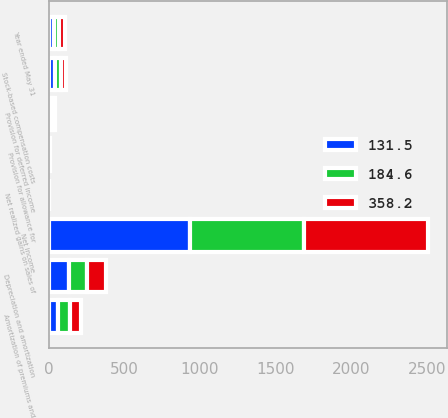Convert chart to OTSL. <chart><loc_0><loc_0><loc_500><loc_500><stacked_bar_chart><ecel><fcel>Year ended May 31<fcel>Net income<fcel>Depreciation and amortization<fcel>Amortization of premiums and<fcel>Stock-based compensation costs<fcel>Provision for deferred income<fcel>Provision for allowance for<fcel>Net realized gains on sales of<nl><fcel>131.5<fcel>35.4<fcel>933.7<fcel>138<fcel>65.4<fcel>44.6<fcel>19.2<fcel>3.6<fcel>0.1<nl><fcel>358.2<fcel>35.4<fcel>817.3<fcel>126.9<fcel>72.5<fcel>35.4<fcel>17.4<fcel>4.9<fcel>0.1<nl><fcel>184.6<fcel>35.4<fcel>756.8<fcel>115.1<fcel>75.7<fcel>34.6<fcel>7.1<fcel>2.5<fcel>0.1<nl></chart> 